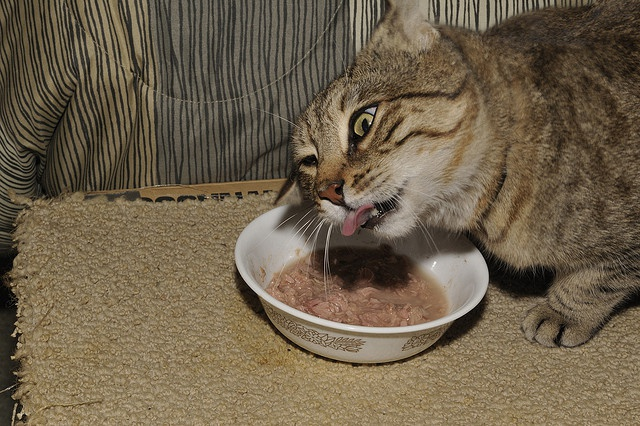Describe the objects in this image and their specific colors. I can see couch in black, gray, and tan tones, cat in black and gray tones, and bowl in black, darkgray, and gray tones in this image. 